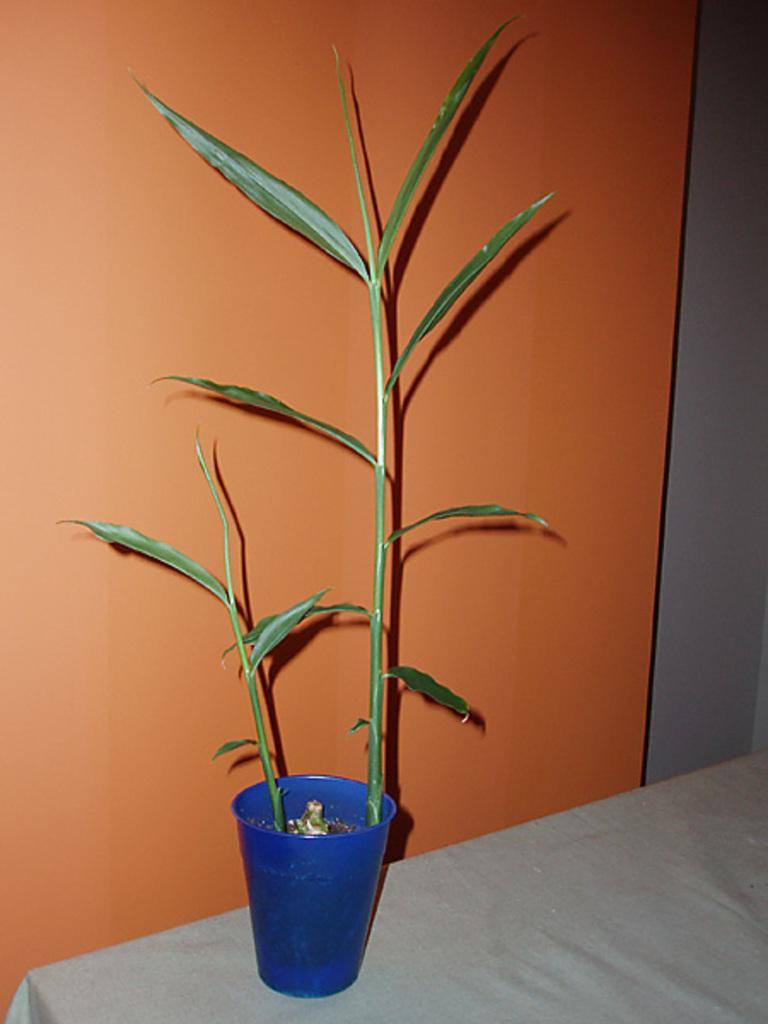What type of plant is in the image? There is a small bamboo plant in the image. What color is the pot that the bamboo plant is in? The pot is blue. Where is the pot with the bamboo plant located? The pot is placed on a table top. What can be seen in the background of the image? There is an orange color wall in the background of the image. How does the pig interact with the bamboo plant in the image? There is no pig present in the image, so it cannot interact with the bamboo plant. 